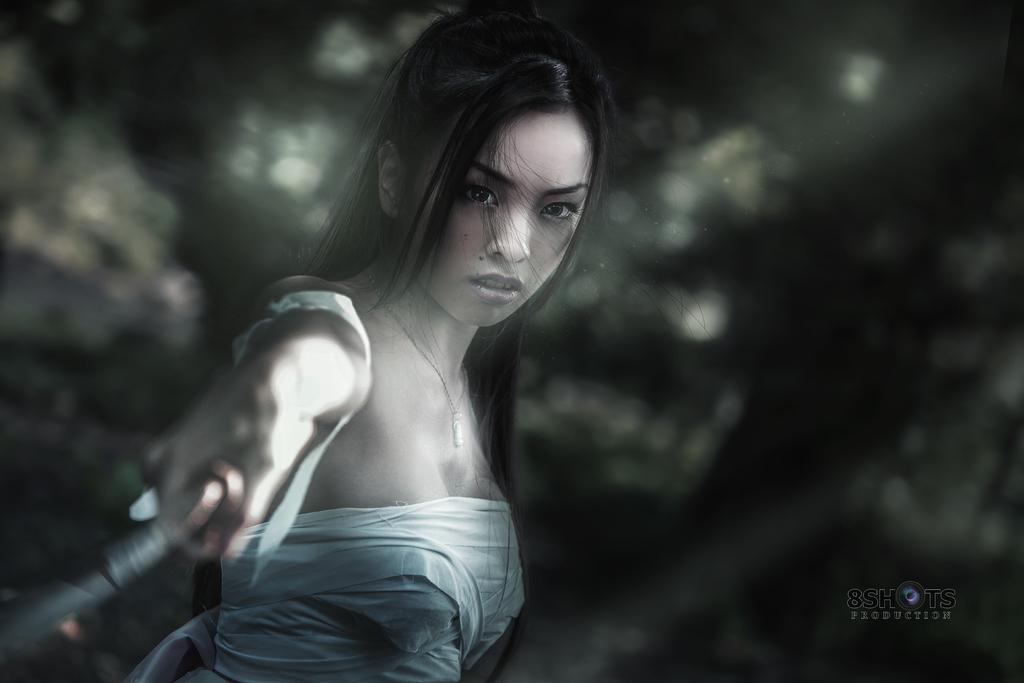What is the lady doing in the image? The lady is holding an object in the center of the image. Can you describe the background of the image? The background of the image is blurry. Is there any text present in the image? Yes, there is some text visible at the bottom of the image. How many babies are visible in the image? There are no babies present in the image. 